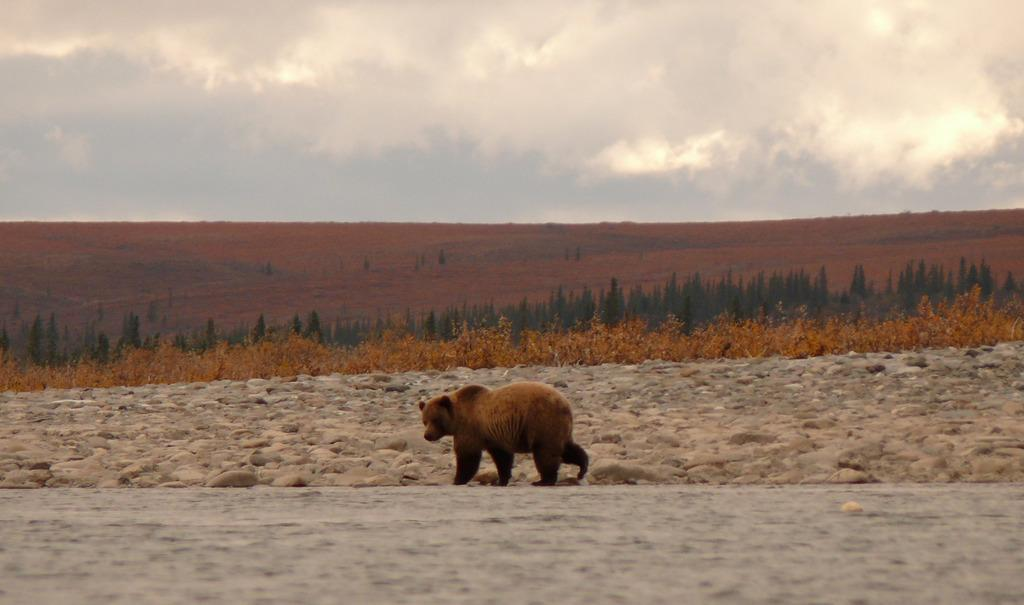What animal is on the ground in the image? There is a bear on the ground in the image. What type of natural environment is visible in the background of the image? There are trees in the background of the image. What part of the natural environment is visible in the image? The sky is visible in the background of the image. What type of magic is the bear performing in the image? There is no indication of magic or any magical activity in the image; it simply shows a bear on the ground. 